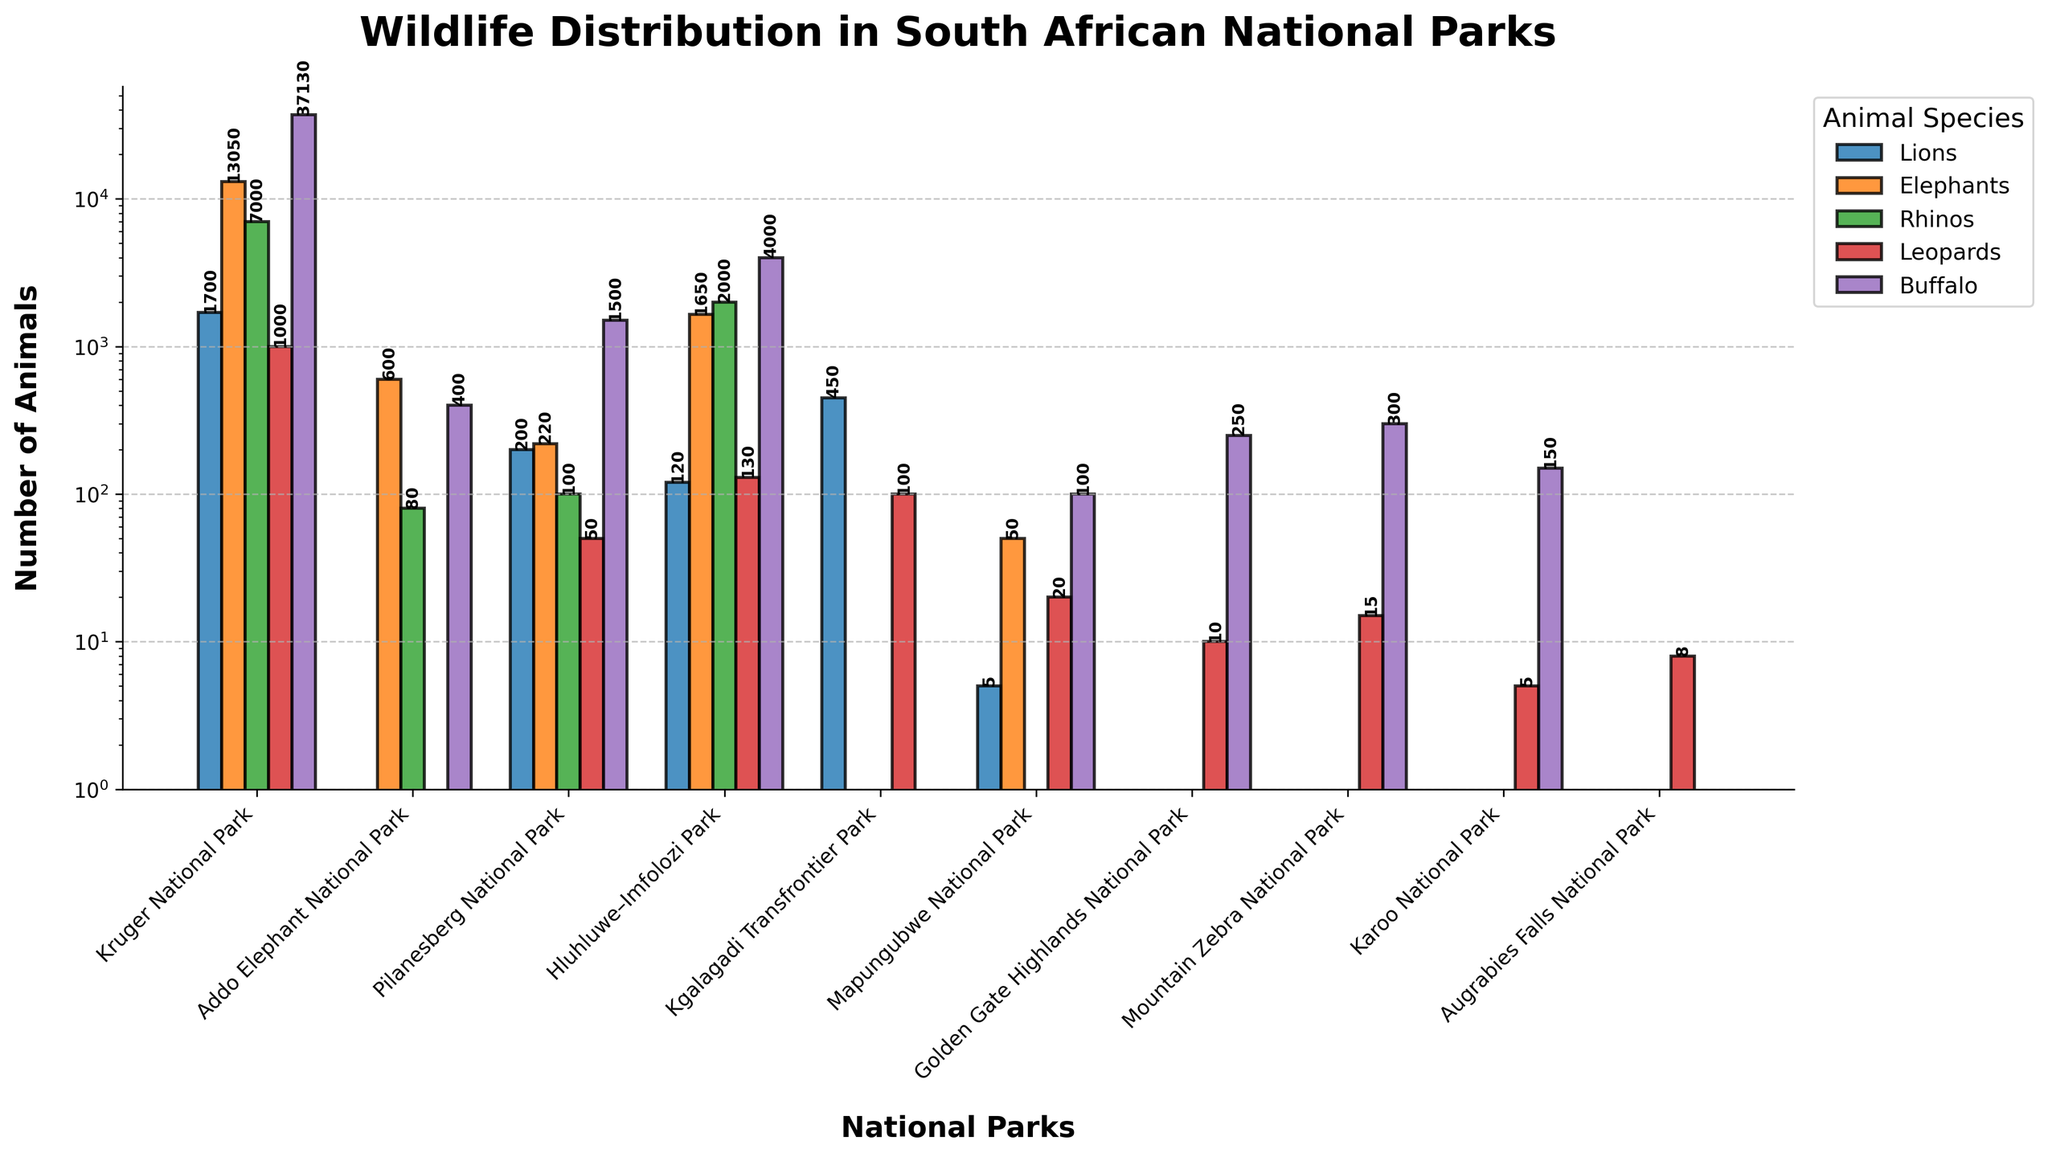Which park has the highest number of Lions? By examining the bar heights for Lions, we can see that Kruger National Park has the tallest bar in terms of the number of Lions.
Answer: Kruger National Park How many Elephants are there in Addo Elephant National Park and Pilanesberg National Park combined? By adding the values of Elephants in Addo Elephant National Park (600) and Pilanesberg National Park (220), we get 600 + 220 = 820.
Answer: 820 Which park has more Rhinos, Hluhluwe–Imfolozi Park or Kruger National Park? By comparing the heights of the bars representing Rhinos, we find that Hluhluwe–Imfolozi Park has 2000 Rhinos whereas Kruger National Park has 7000 Rhinos. Kruger National Park has more Rhinos.
Answer: Kruger National Park Which animal species is exclusive to Kruger National Park? By looking at the data, the Buffalo species has significant representation in Kruger National Park (37130) while other parks have fewer numbers except Hluhluwe–Imfolozi Park (4000). However, Kruger National Park has a consistent representation higher in comparison.
Answer: Buffalo Which park has the fewest types of animals counted in this chart? By checking the number of species bars present in each park, Augrabies Falls National Park only has 1 species, which is Leopards (8).
Answer: Augrabies Falls National Park What is the total number of Buffalo across all parks? By summing up the values given for Buffalo across all parks: 37130 (Kruger) + 400 (Addo) + 1500 (Pilanesberg) + 4000 (Hluhluwe–Imfolozi) + 100 (Mapungubwe) + 250 (Golden Gate) + 300 (Mountain Zebra) + 150 (Karoo), it totals to 43790.
Answer: 43790 In which park is the presence of Leopards relatively high compared to other species within the same park? By examining the relative height of bars in each park, Hluhluwe–Imfolozi Park has a notable presence of Leopards (130) when compared to other species like Elephants (1650) and Rhinos (2000), making it significant relative to the overall wildlife distribution of this specific park.
Answer: Hluhluwe–Imfolozi Park Which park has the broadest diversity (number of different types) of wildlife species? By counting the different types of species bars in each park, Kruger National Park holds the highest number, featuring all five species: Lions, Elephants, Rhinos, Leopards, and Buffalo.
Answer: Kruger National Park How many more Elephants are there in Kruger National Park compared to all other parks combined? Adding the Elephant counts from all parks except Kruger: 600 (Addo) + 220 (Pilanesberg) + 1650 (Hluhluwe–Imfolozi) + 50 (Mapungubwe) = 2520 Elephants. Kruger has 13050 Elephants; the difference is 13050 - 2520 = 10530.
Answer: 10530 Which parks have no Lions at all? By checking the Lions' data column, we see that Addo Elephant National Park, Golden Gate Highlands National Park, Mountain Zebra National Park, Karoo National Park, and Augrabies Falls National Park all have a value of 0 for Lions.
Answer: Addo Elephant National Park, Golden Gate Highlands National Park, Mountain Zebra National Park, Karoo National Park, Augrabies Falls National Park 